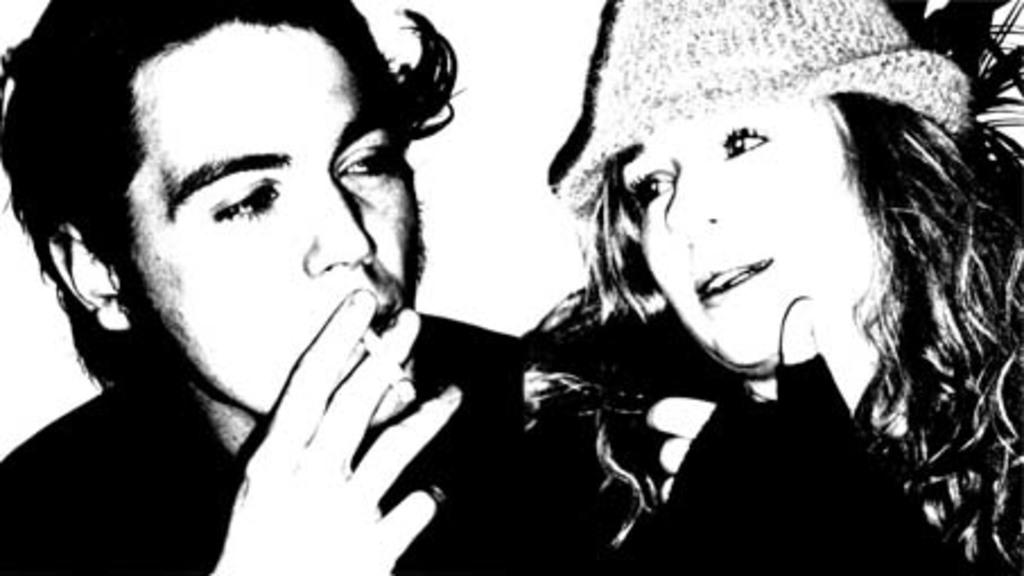How many people are in the image? There are two people in the image. What is one of the people holding? One person is holding a cigarette. Where is the receipt for the pump located in the image? There is no receipt or pump present in the image. 